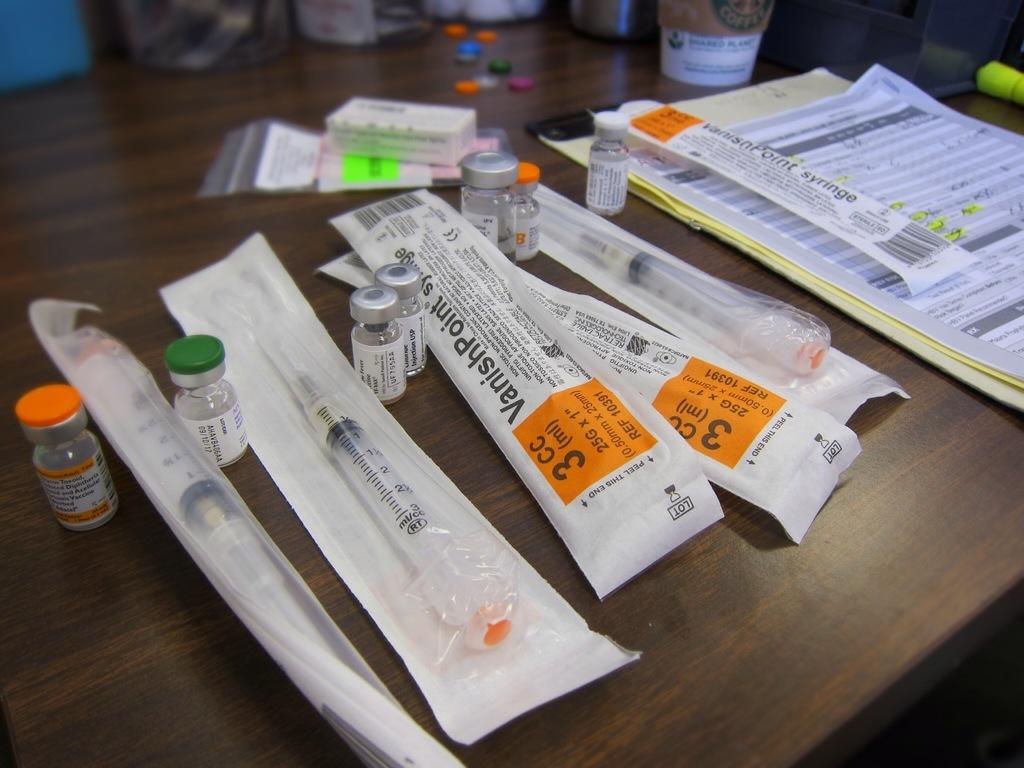<image>
Create a compact narrative representing the image presented. Several packages of VanishPoint syringes on a wooden table. 